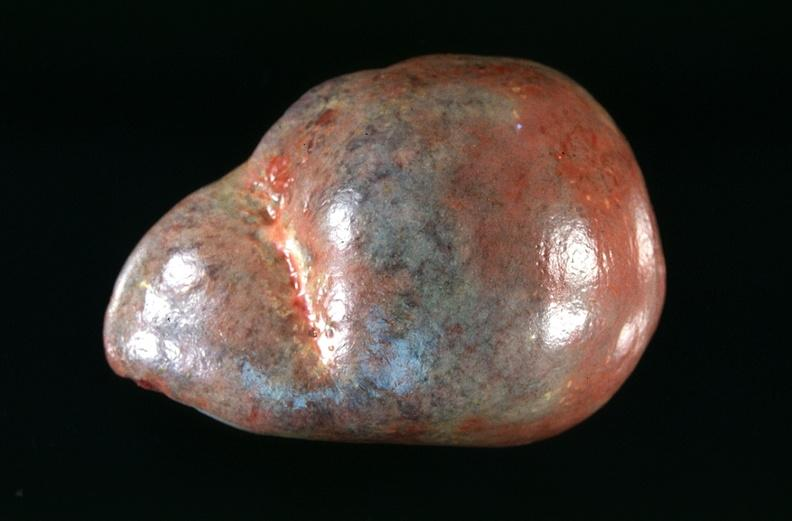where is this part in?
Answer the question using a single word or phrase. Spleen 